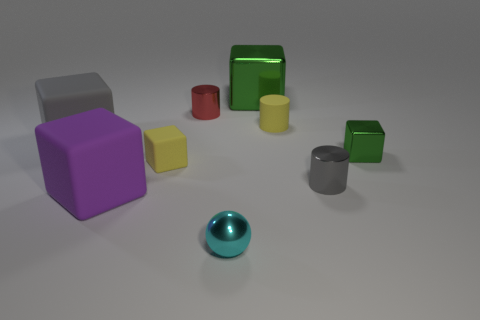What is the material of the purple block?
Your response must be concise. Rubber. How many things are either tiny green objects or big gray rubber cubes?
Your answer should be compact. 2. What size is the gray object on the right side of the purple cube?
Provide a succinct answer. Small. What number of other things are there of the same material as the small cyan ball
Keep it short and to the point. 4. Are there any tiny yellow objects behind the small metallic thing that is right of the tiny gray cylinder?
Give a very brief answer. Yes. Are there any other things that are the same shape as the tiny cyan metallic object?
Offer a very short reply. No. What color is the other tiny rubber thing that is the same shape as the small green object?
Your answer should be compact. Yellow. What size is the purple cube?
Your answer should be very brief. Large. Are there fewer tiny blocks that are in front of the big purple matte block than rubber cubes?
Keep it short and to the point. Yes. Does the big green block have the same material as the tiny cylinder on the left side of the small sphere?
Keep it short and to the point. Yes. 